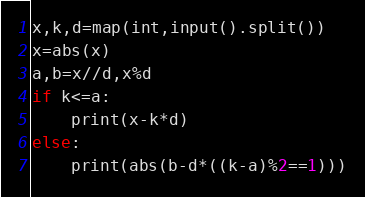<code> <loc_0><loc_0><loc_500><loc_500><_Python_>x,k,d=map(int,input().split())
x=abs(x)
a,b=x//d,x%d
if k<=a:
    print(x-k*d)
else:
    print(abs(b-d*((k-a)%2==1)))</code> 